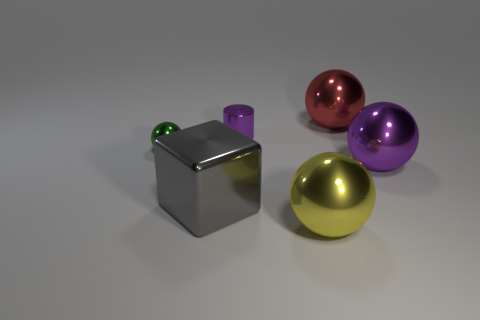Subtract all green spheres. How many spheres are left? 3 Subtract all red metallic balls. How many balls are left? 3 Add 2 large green matte objects. How many objects exist? 8 Subtract all cyan spheres. Subtract all blue blocks. How many spheres are left? 4 Subtract all spheres. How many objects are left? 2 Add 5 yellow blocks. How many yellow blocks exist? 5 Subtract 1 purple cylinders. How many objects are left? 5 Subtract all tiny metal cylinders. Subtract all green things. How many objects are left? 4 Add 6 red balls. How many red balls are left? 7 